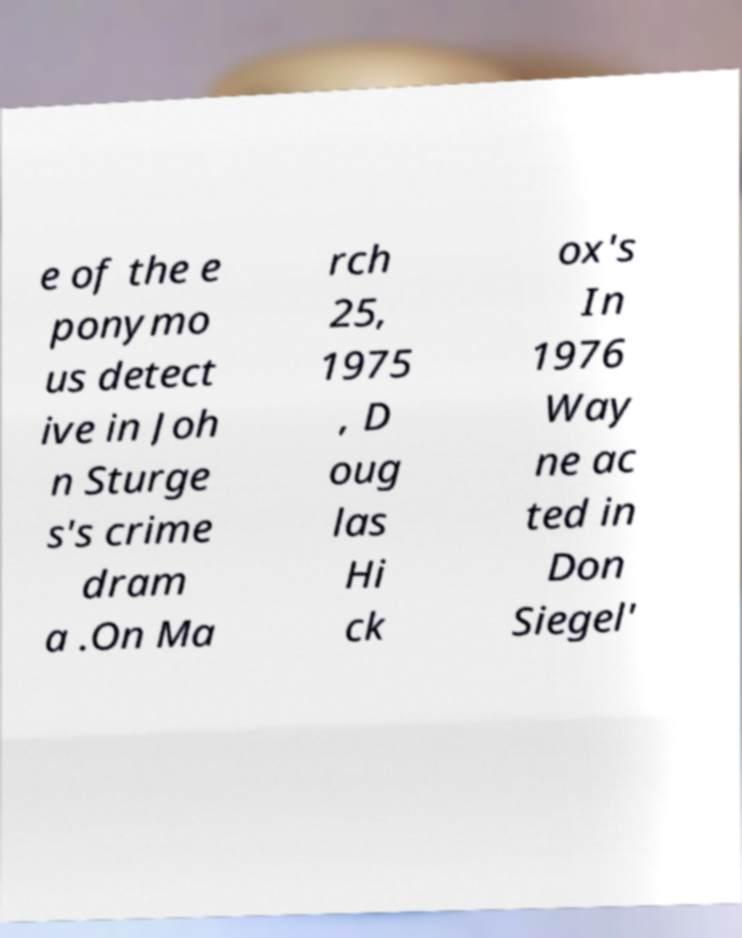What messages or text are displayed in this image? I need them in a readable, typed format. e of the e ponymo us detect ive in Joh n Sturge s's crime dram a .On Ma rch 25, 1975 , D oug las Hi ck ox's In 1976 Way ne ac ted in Don Siegel' 